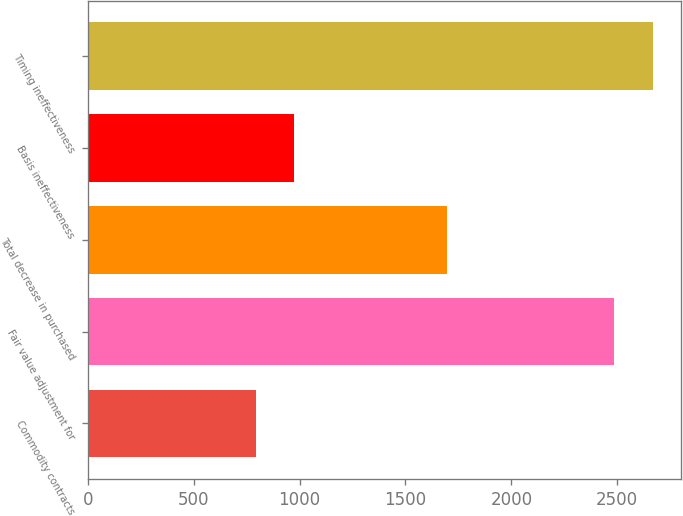Convert chart to OTSL. <chart><loc_0><loc_0><loc_500><loc_500><bar_chart><fcel>Commodity contracts<fcel>Fair value adjustment for<fcel>Total decrease in purchased<fcel>Basis ineffectiveness<fcel>Timing ineffectiveness<nl><fcel>792<fcel>2486<fcel>1694<fcel>974.1<fcel>2668.1<nl></chart> 